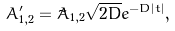Convert formula to latex. <formula><loc_0><loc_0><loc_500><loc_500>A ^ { \prime } _ { 1 , 2 } = \tilde { A } _ { 1 , 2 } \sqrt { 2 D } e ^ { - D | t | } ,</formula> 